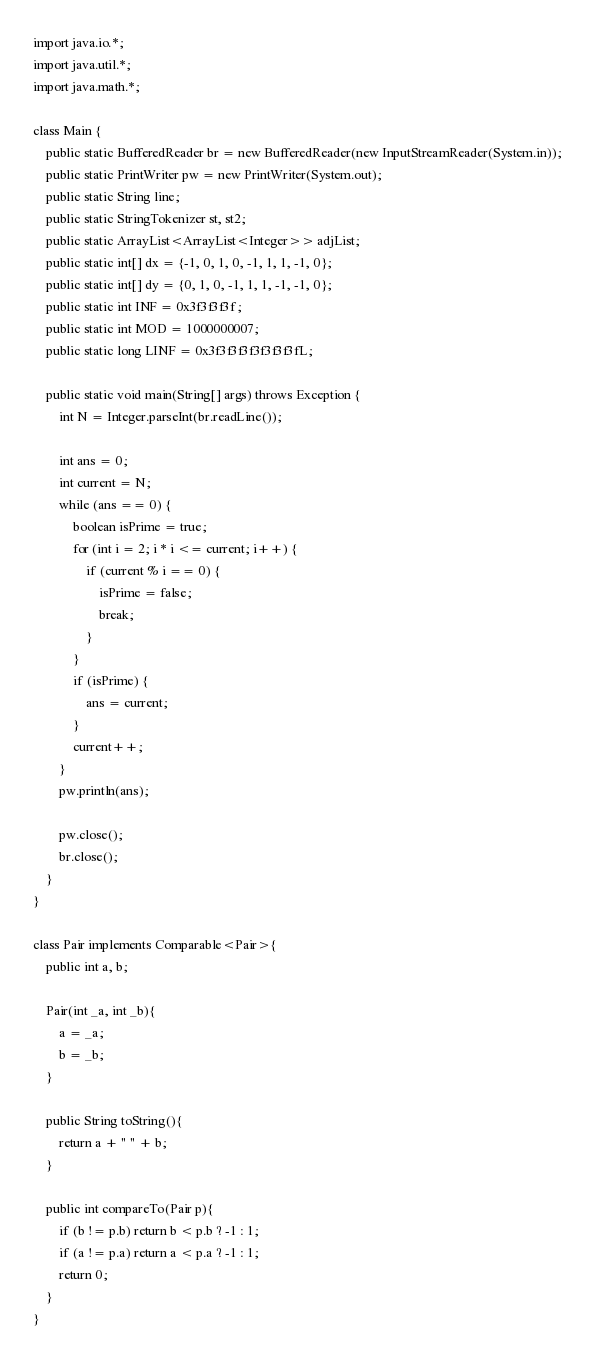Convert code to text. <code><loc_0><loc_0><loc_500><loc_500><_Java_>import java.io.*;
import java.util.*;
import java.math.*;
 
class Main {
    public static BufferedReader br = new BufferedReader(new InputStreamReader(System.in));
    public static PrintWriter pw = new PrintWriter(System.out);
    public static String line;
    public static StringTokenizer st, st2;
    public static ArrayList<ArrayList<Integer>> adjList;
    public static int[] dx = {-1, 0, 1, 0, -1, 1, 1, -1, 0};
    public static int[] dy = {0, 1, 0, -1, 1, 1, -1, -1, 0};
    public static int INF = 0x3f3f3f3f;
    public static int MOD = 1000000007;
    public static long LINF = 0x3f3f3f3f3f3f3f3fL;

    public static void main(String[] args) throws Exception {
        int N = Integer.parseInt(br.readLine());

        int ans = 0;
        int current = N;
        while (ans == 0) {
            boolean isPrime = true;
            for (int i = 2; i * i <= current; i++) {
                if (current % i == 0) {
                    isPrime = false;
                    break;
                }
            }
            if (isPrime) {
                ans = current;
            }
            current++;
        }
        pw.println(ans);

        pw.close();
        br.close();
    }
}

class Pair implements Comparable<Pair>{
    public int a, b;

    Pair(int _a, int _b){
        a = _a;
        b = _b;
    }
 
    public String toString(){
        return a + " " + b;
    }

    public int compareTo(Pair p){
        if (b != p.b) return b < p.b ? -1 : 1;
        if (a != p.a) return a < p.a ? -1 : 1;
        return 0;
    }
}</code> 